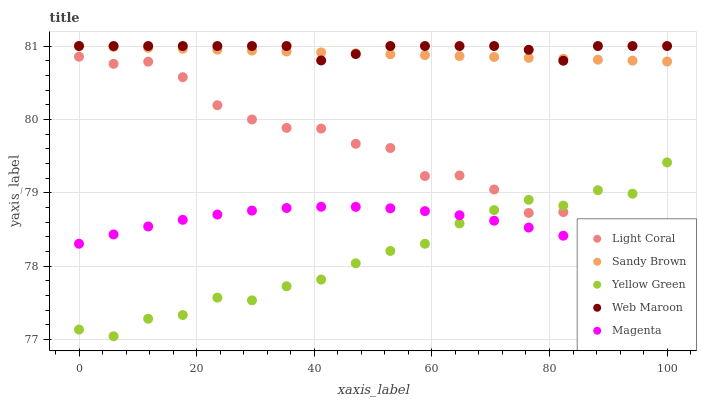Does Yellow Green have the minimum area under the curve?
Answer yes or no. Yes. Does Web Maroon have the maximum area under the curve?
Answer yes or no. Yes. Does Magenta have the minimum area under the curve?
Answer yes or no. No. Does Magenta have the maximum area under the curve?
Answer yes or no. No. Is Sandy Brown the smoothest?
Answer yes or no. Yes. Is Light Coral the roughest?
Answer yes or no. Yes. Is Web Maroon the smoothest?
Answer yes or no. No. Is Web Maroon the roughest?
Answer yes or no. No. Does Yellow Green have the lowest value?
Answer yes or no. Yes. Does Magenta have the lowest value?
Answer yes or no. No. Does Sandy Brown have the highest value?
Answer yes or no. Yes. Does Magenta have the highest value?
Answer yes or no. No. Is Yellow Green less than Sandy Brown?
Answer yes or no. Yes. Is Sandy Brown greater than Yellow Green?
Answer yes or no. Yes. Does Web Maroon intersect Sandy Brown?
Answer yes or no. Yes. Is Web Maroon less than Sandy Brown?
Answer yes or no. No. Is Web Maroon greater than Sandy Brown?
Answer yes or no. No. Does Yellow Green intersect Sandy Brown?
Answer yes or no. No. 